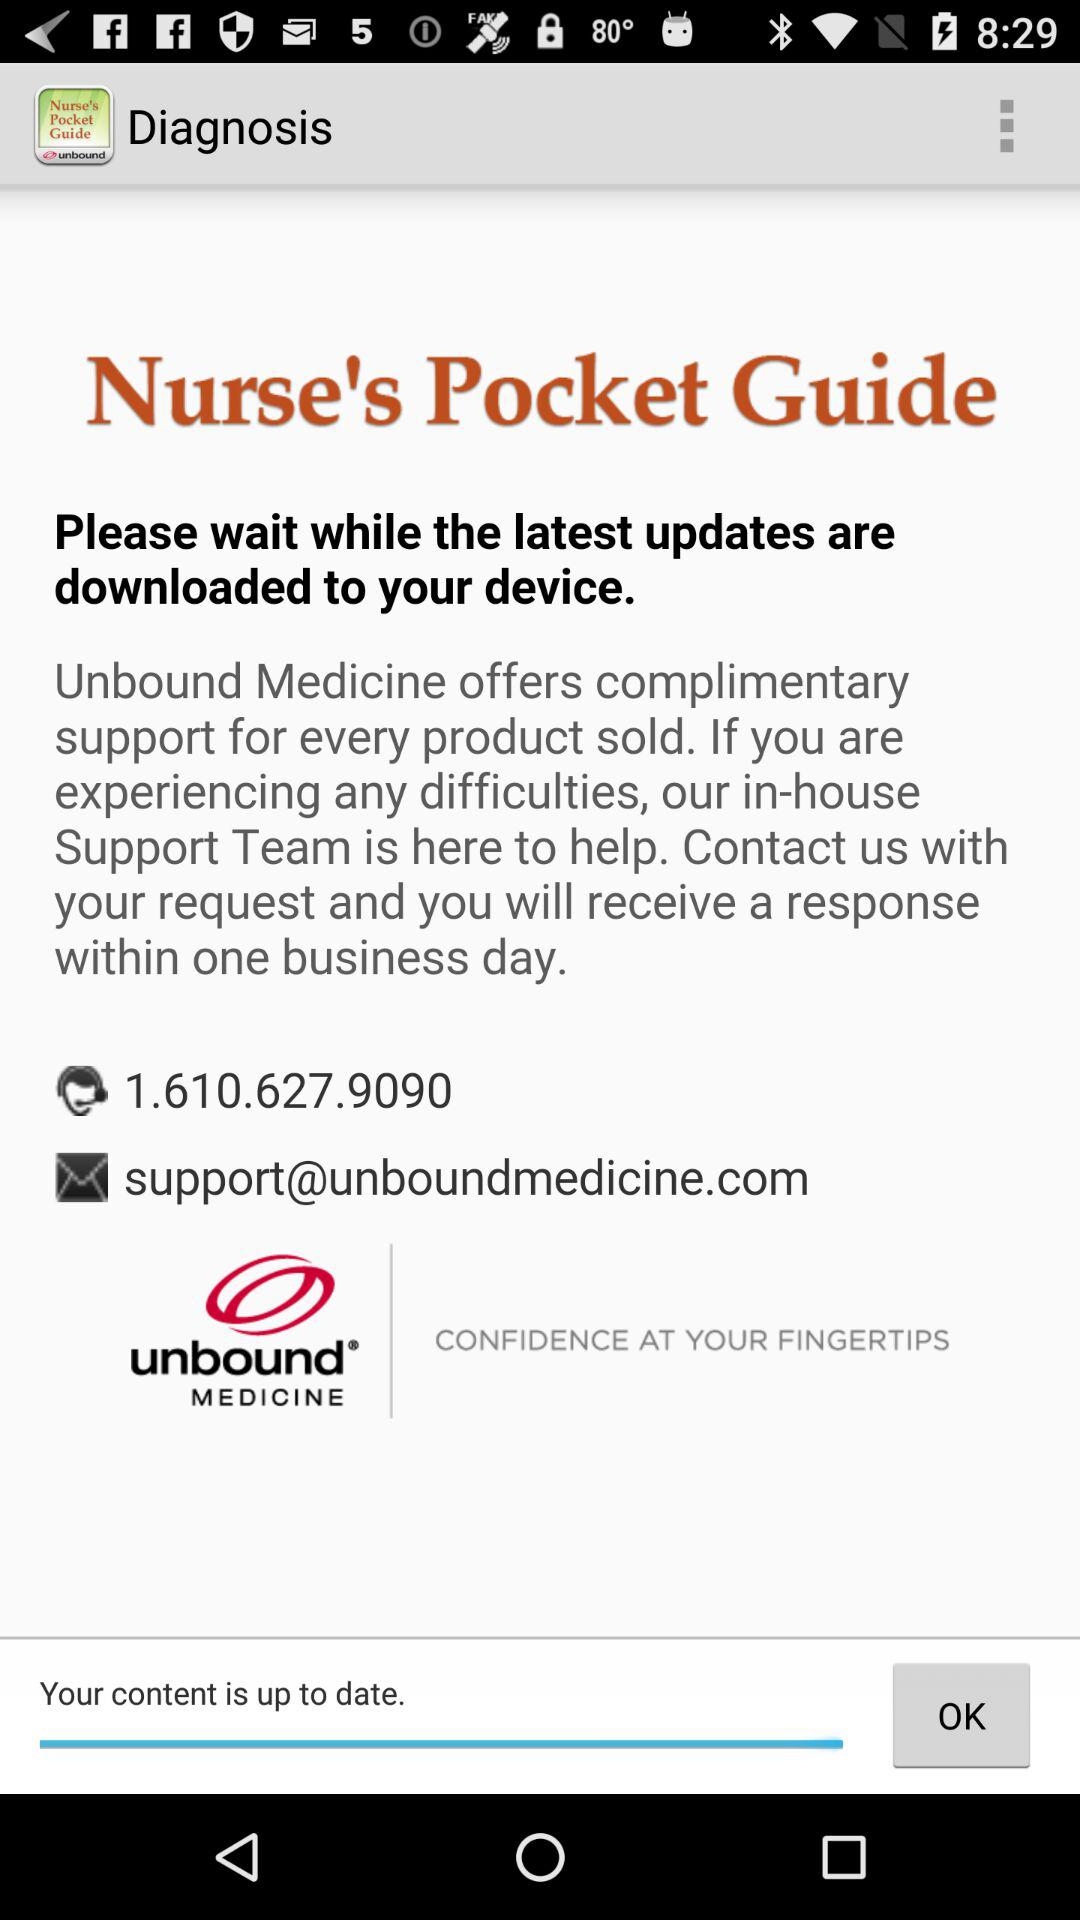What is the email address? The email address is support@unboundmedicine.com. 